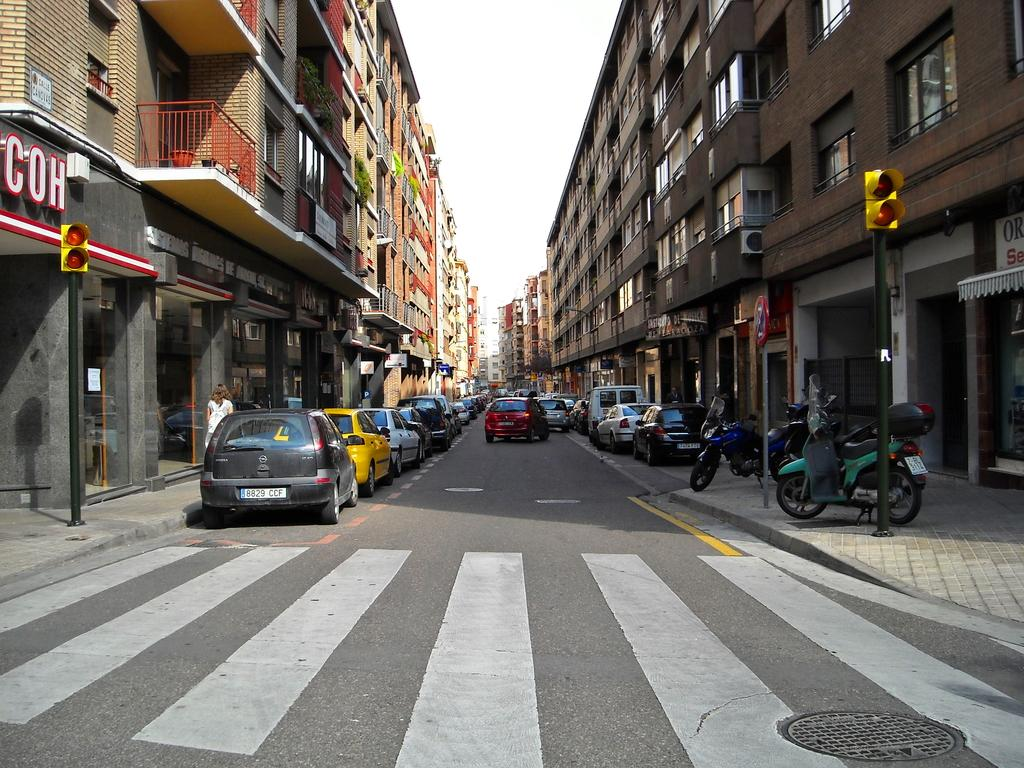What is the main subject of the image? The image depicts a road. Are there any vehicles visible on the road? No, there are no vehicles on the road, but there are parked cars on the left side of the road. What can be seen on either side of the road? There are buildings on either side of the road. What hobbies do the buildings on either side of the road have? Buildings do not have hobbies, as they are inanimate objects. 